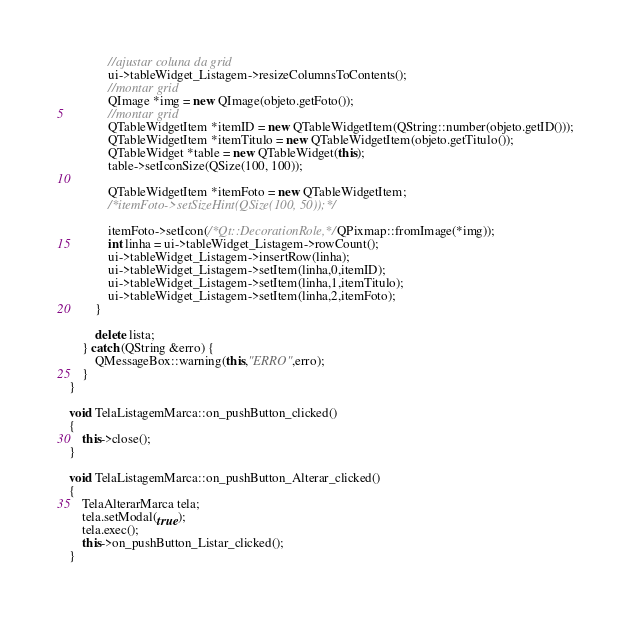<code> <loc_0><loc_0><loc_500><loc_500><_C++_>            //ajustar coluna da grid
            ui->tableWidget_Listagem->resizeColumnsToContents();
            //montar grid
            QImage *img = new QImage(objeto.getFoto());
            //montar grid
            QTableWidgetItem *itemID = new QTableWidgetItem(QString::number(objeto.getID()));
            QTableWidgetItem *itemTitulo = new QTableWidgetItem(objeto.getTitulo());
            QTableWidget *table = new QTableWidget(this);
            table->setIconSize(QSize(100, 100));

            QTableWidgetItem *itemFoto = new QTableWidgetItem;
            /*itemFoto->setSizeHint(QSize(100, 50));*/

            itemFoto->setIcon(/*Qt::DecorationRole,*/ QPixmap::fromImage(*img));
            int linha = ui->tableWidget_Listagem->rowCount();
            ui->tableWidget_Listagem->insertRow(linha);
            ui->tableWidget_Listagem->setItem(linha,0,itemID);
            ui->tableWidget_Listagem->setItem(linha,1,itemTitulo);
            ui->tableWidget_Listagem->setItem(linha,2,itemFoto);
        }

        delete lista;
    } catch (QString &erro) {
        QMessageBox::warning(this,"ERRO",erro);
    }
}

void TelaListagemMarca::on_pushButton_clicked()
{
    this->close();
}

void TelaListagemMarca::on_pushButton_Alterar_clicked()
{
    TelaAlterarMarca tela;
    tela.setModal(true);
    tela.exec();
    this->on_pushButton_Listar_clicked();
}
</code> 